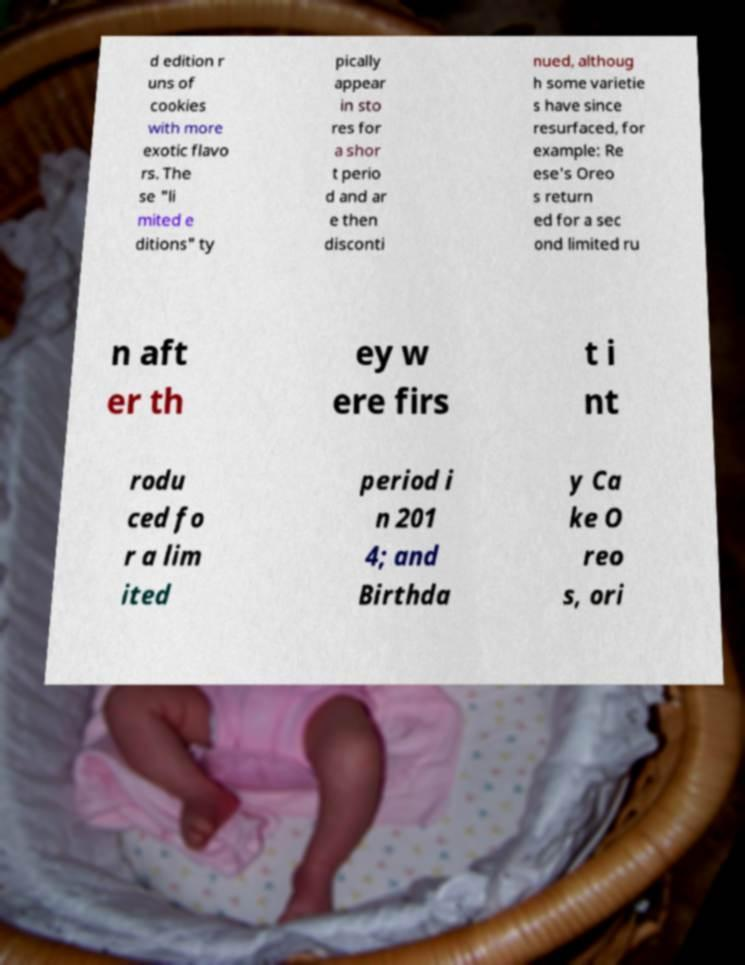Can you accurately transcribe the text from the provided image for me? d edition r uns of cookies with more exotic flavo rs. The se "li mited e ditions" ty pically appear in sto res for a shor t perio d and ar e then disconti nued, althoug h some varietie s have since resurfaced, for example: Re ese's Oreo s return ed for a sec ond limited ru n aft er th ey w ere firs t i nt rodu ced fo r a lim ited period i n 201 4; and Birthda y Ca ke O reo s, ori 